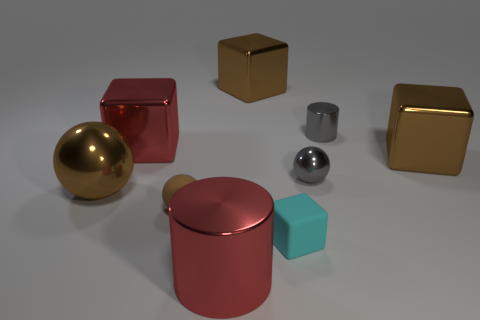Subtract 1 blocks. How many blocks are left? 3 Subtract all blocks. How many objects are left? 5 Subtract all tiny red blocks. Subtract all red metal objects. How many objects are left? 7 Add 2 tiny things. How many tiny things are left? 6 Add 9 gray matte spheres. How many gray matte spheres exist? 9 Subtract 1 brown spheres. How many objects are left? 8 